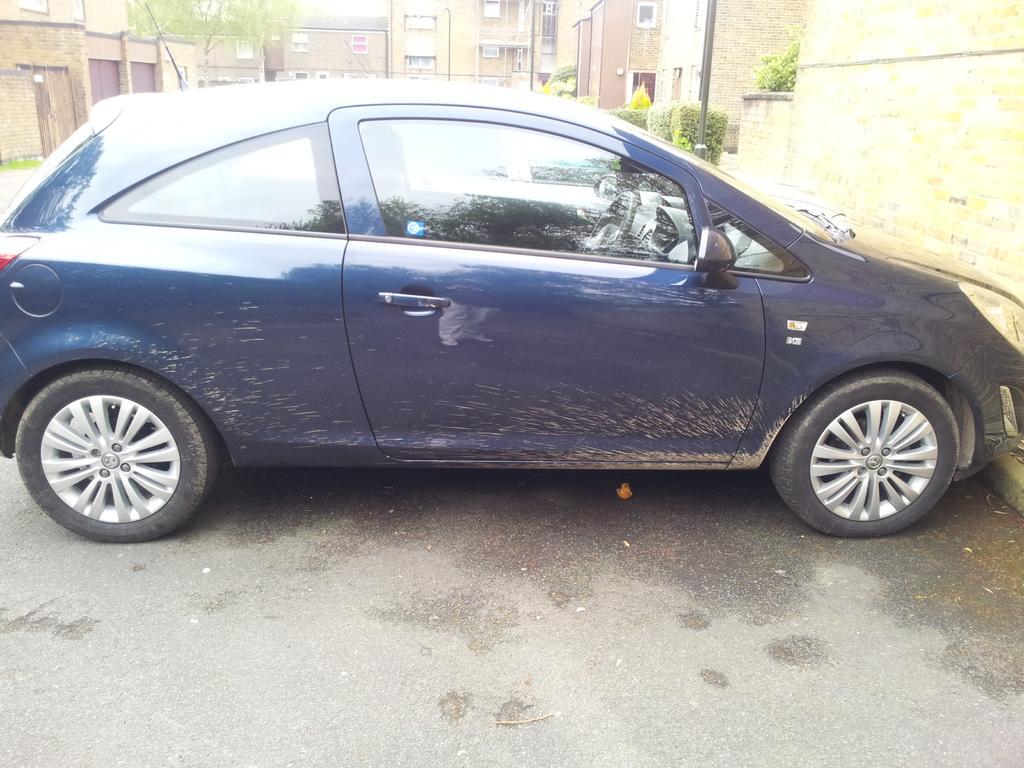Can you describe this image briefly? In this image, I can see a car, which is parked. These are the buildings. I can see the bushes and a tree. I think this is a road. 